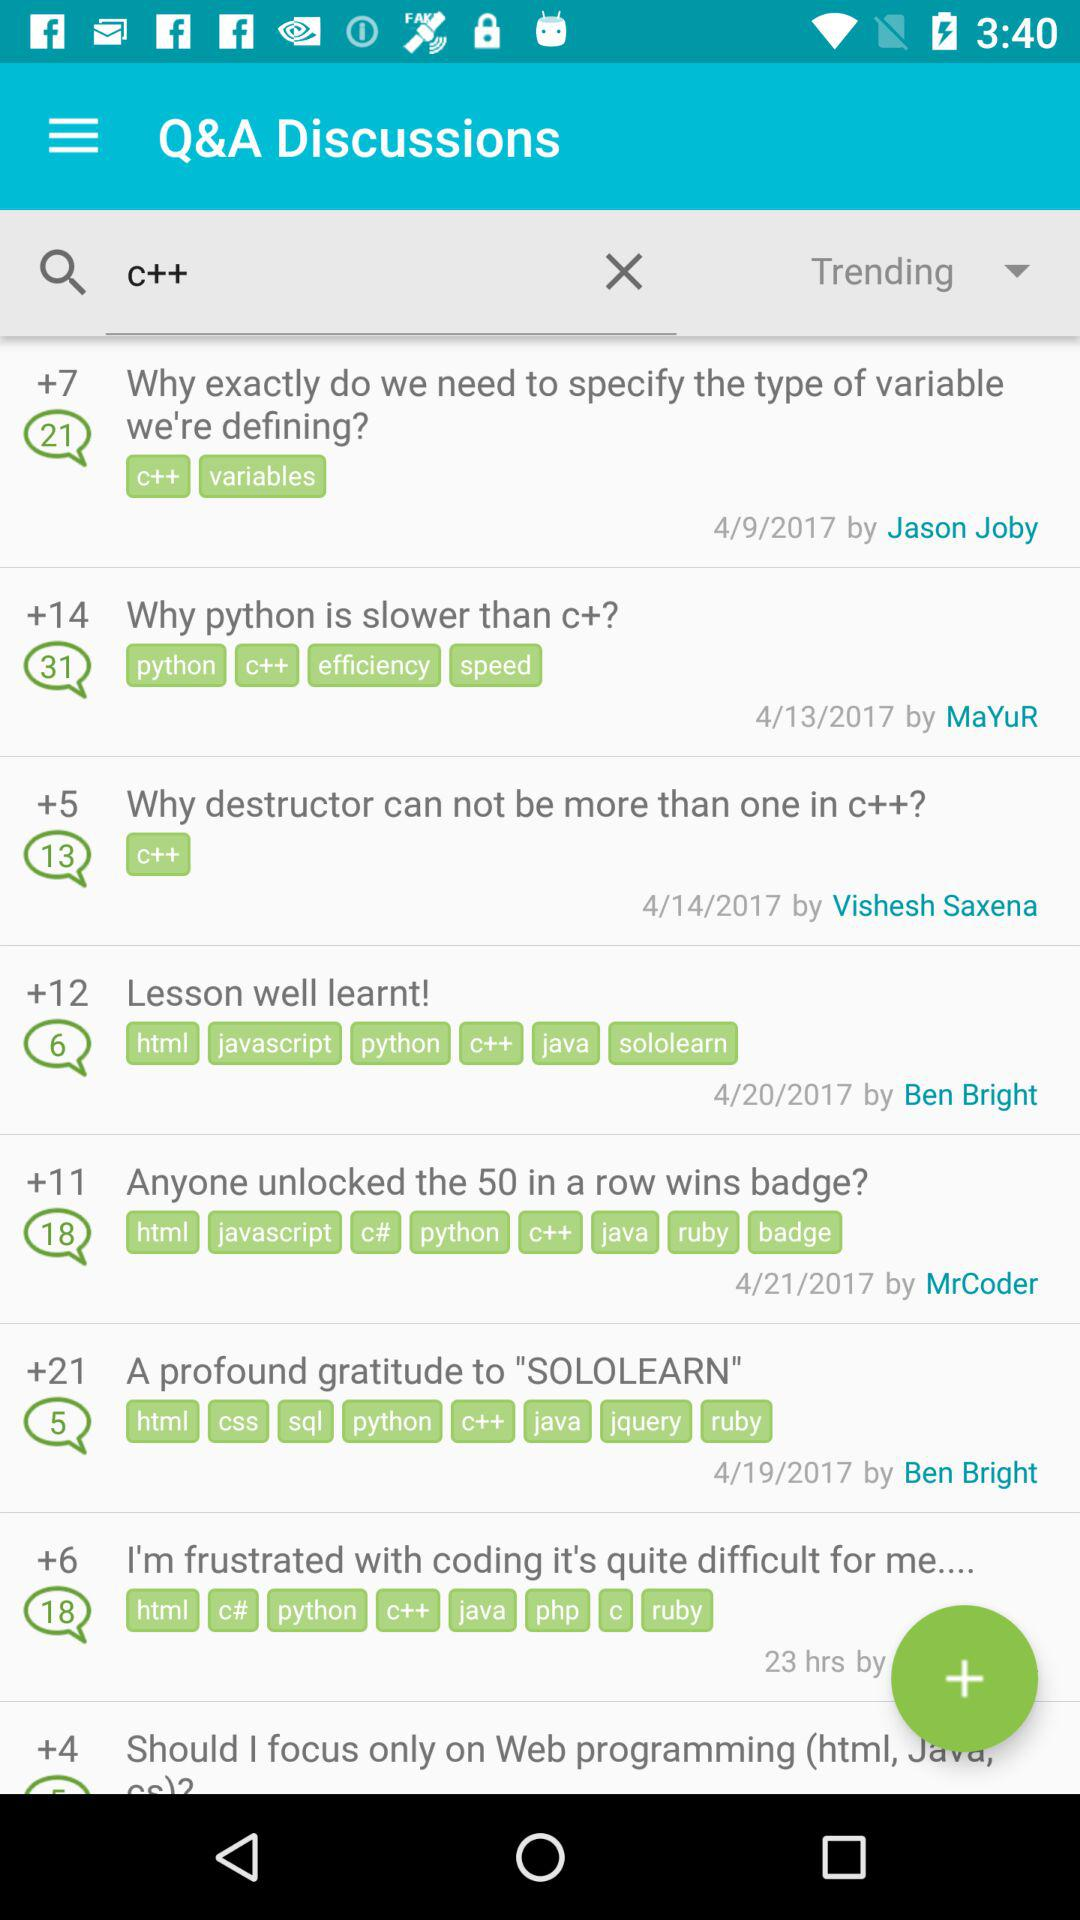How many comments are shown in "Why destructor can not be more than one in c++?"? There are 13 comments. 